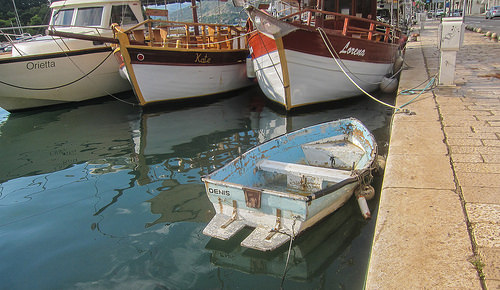<image>
Is there a boat under the ship? No. The boat is not positioned under the ship. The vertical relationship between these objects is different. 